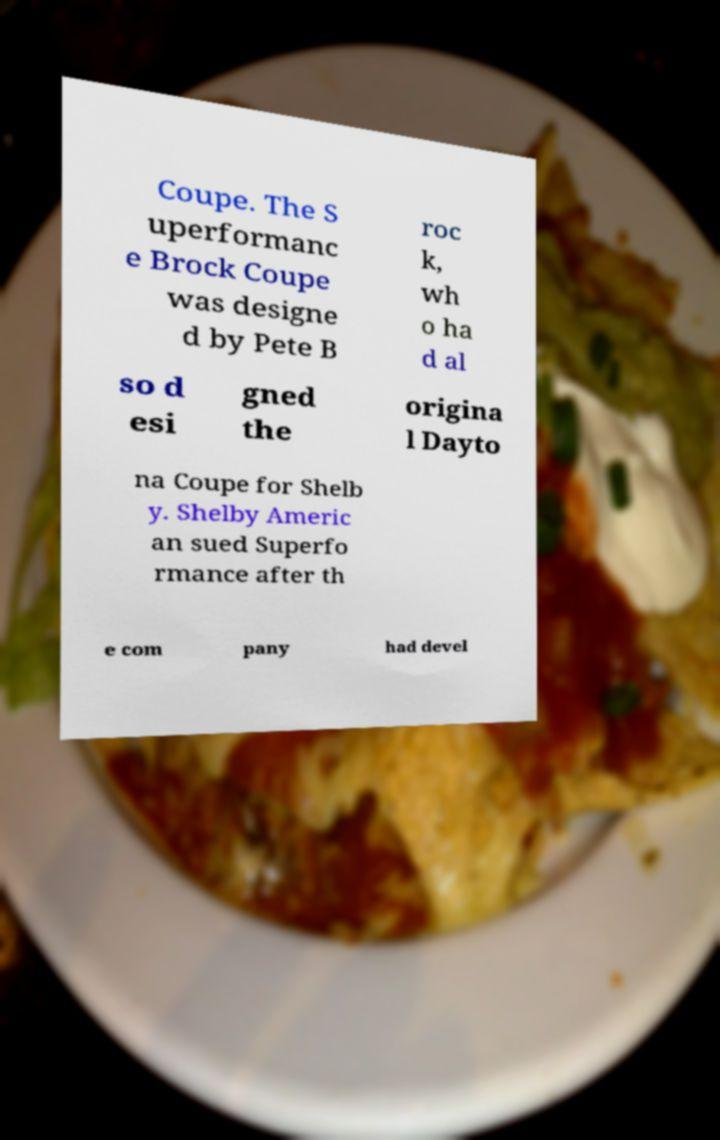Please read and relay the text visible in this image. What does it say? Coupe. The S uperformanc e Brock Coupe was designe d by Pete B roc k, wh o ha d al so d esi gned the origina l Dayto na Coupe for Shelb y. Shelby Americ an sued Superfo rmance after th e com pany had devel 